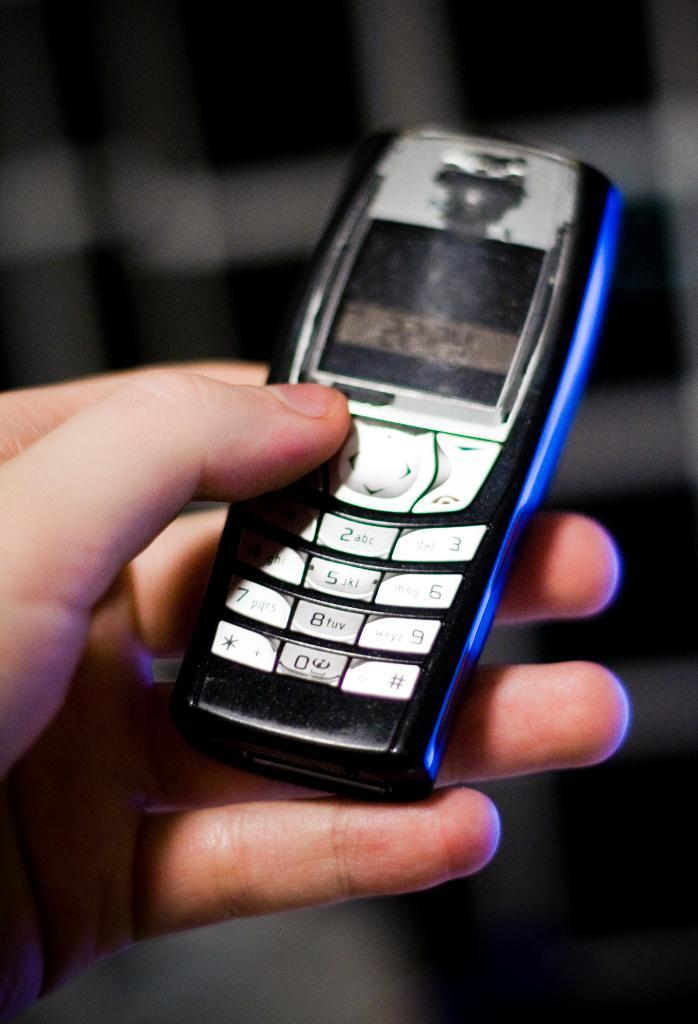What is the main subject of the image? There is a person in the image. What is the person holding in the image? The person is holding a mobile phone. How would you describe the color scheme of the image? The background of the image is in black and white colors. What type of milk can be seen being poured in the image? There is no milk present in the image. On which side of the person is the mobile phone being held? The image does not provide information about the side of the person holding the mobile phone. 